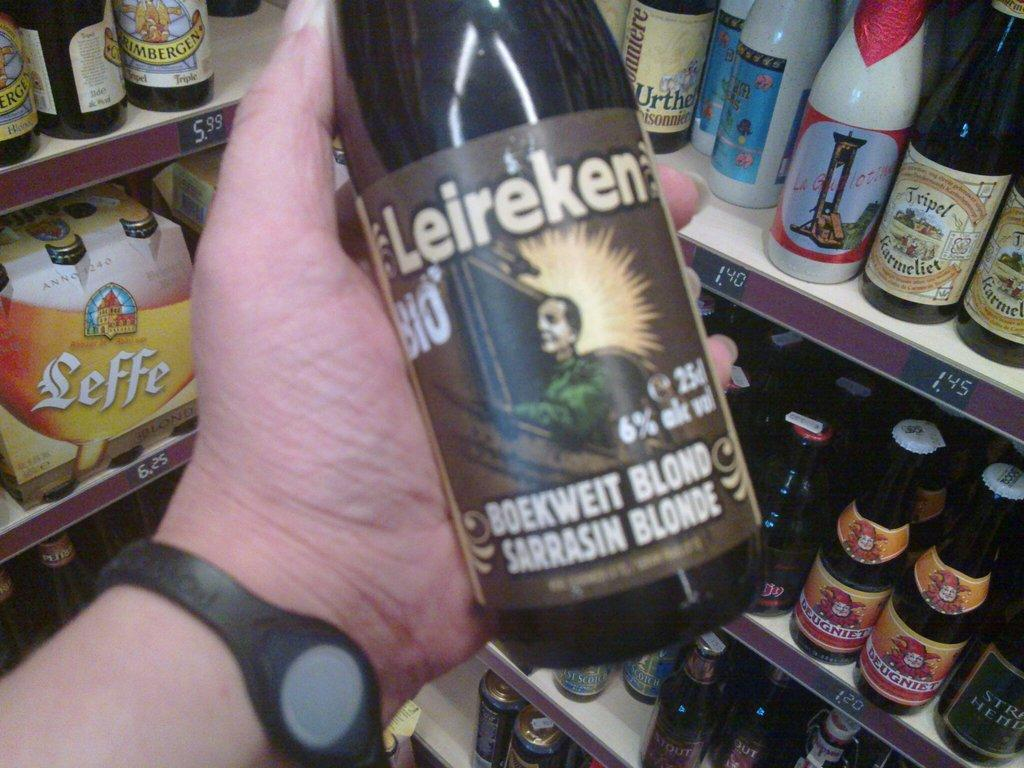<image>
Write a terse but informative summary of the picture. Person holding a bottle of Leireken beer with a man wearing a green shirt on the label. 